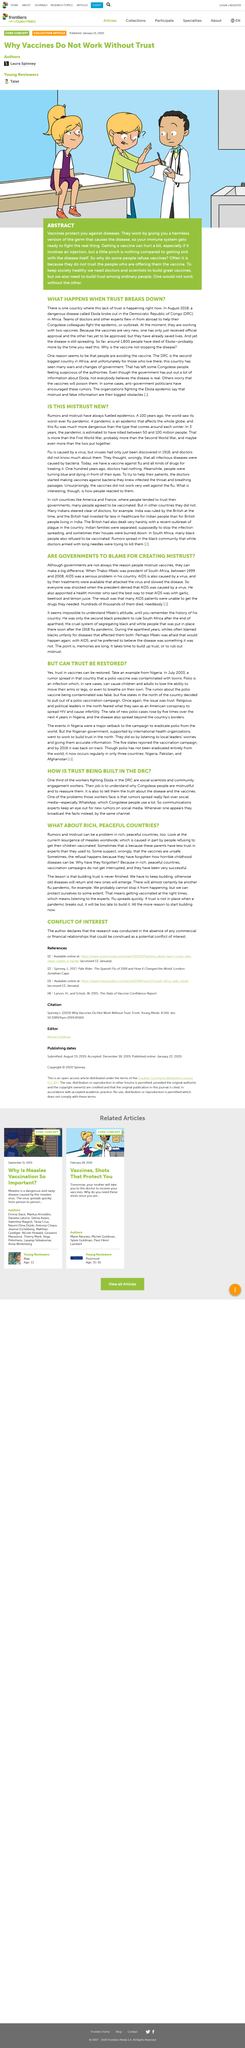Specify some key components in this picture. Flu is caused by a virus, not bacteria. During the flu pandemic 100 years ago, it is estimated that the virus killed between 50 and 100 million people. Polio is an infection that, in rare cases, can lead to the loss of mobility in children and adults, resulting in the inability to move their arms or legs or to breathe independently. The rumor spread that a polio vaccine was contaminated with toxins in Nigeria. On August 2018, Ebola broke out in the Democratic Republic of Congo. 